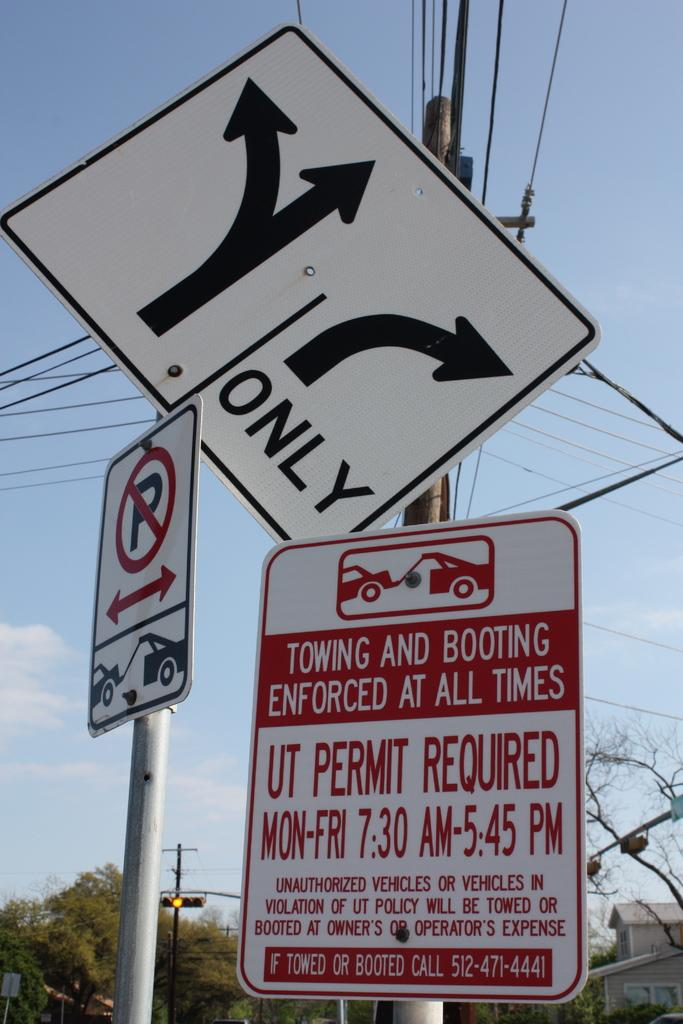Provide a one-sentence caption for the provided image. A sign warns that towing and booting are enforced at all times. 